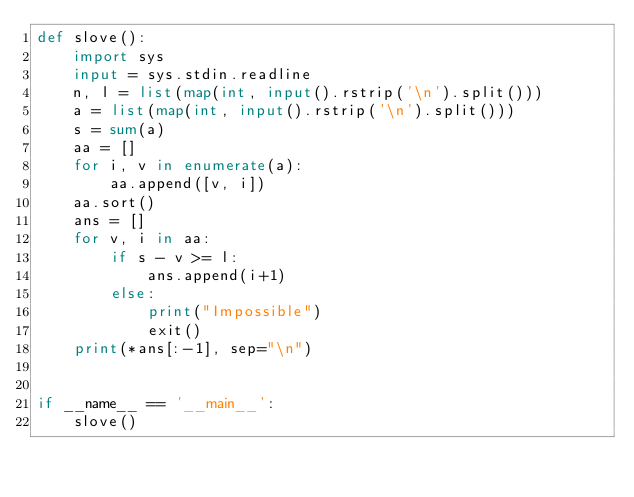<code> <loc_0><loc_0><loc_500><loc_500><_Python_>def slove():
    import sys
    input = sys.stdin.readline
    n, l = list(map(int, input().rstrip('\n').split()))
    a = list(map(int, input().rstrip('\n').split()))
    s = sum(a)
    aa = []
    for i, v in enumerate(a):
        aa.append([v, i])
    aa.sort()
    ans = []
    for v, i in aa:
        if s - v >= l:
            ans.append(i+1)
        else:
            print("Impossible")
            exit()
    print(*ans[:-1], sep="\n")


if __name__ == '__main__':
    slove()
</code> 